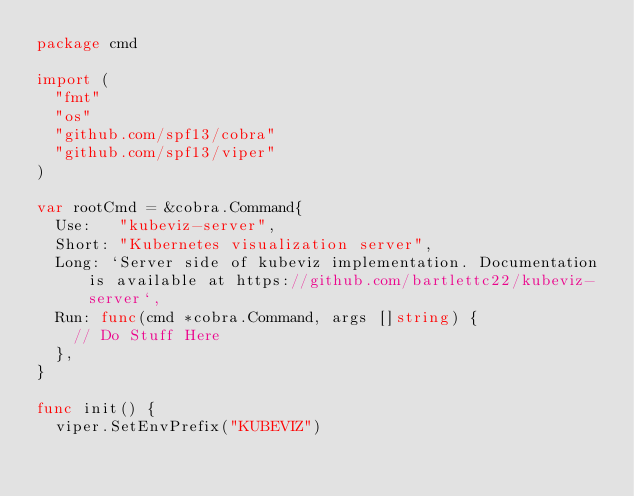<code> <loc_0><loc_0><loc_500><loc_500><_Go_>package cmd

import (
  "fmt"
  "os"
  "github.com/spf13/cobra"
  "github.com/spf13/viper"
)

var rootCmd = &cobra.Command{
  Use:   "kubeviz-server",
  Short: "Kubernetes visualization server",
  Long: `Server side of kubeviz implementation. Documentation is available at https://github.com/bartlettc22/kubeviz-server`,
  Run: func(cmd *cobra.Command, args []string) {
    // Do Stuff Here
  },
}

func init() {
  viper.SetEnvPrefix("KUBEVIZ")</code> 